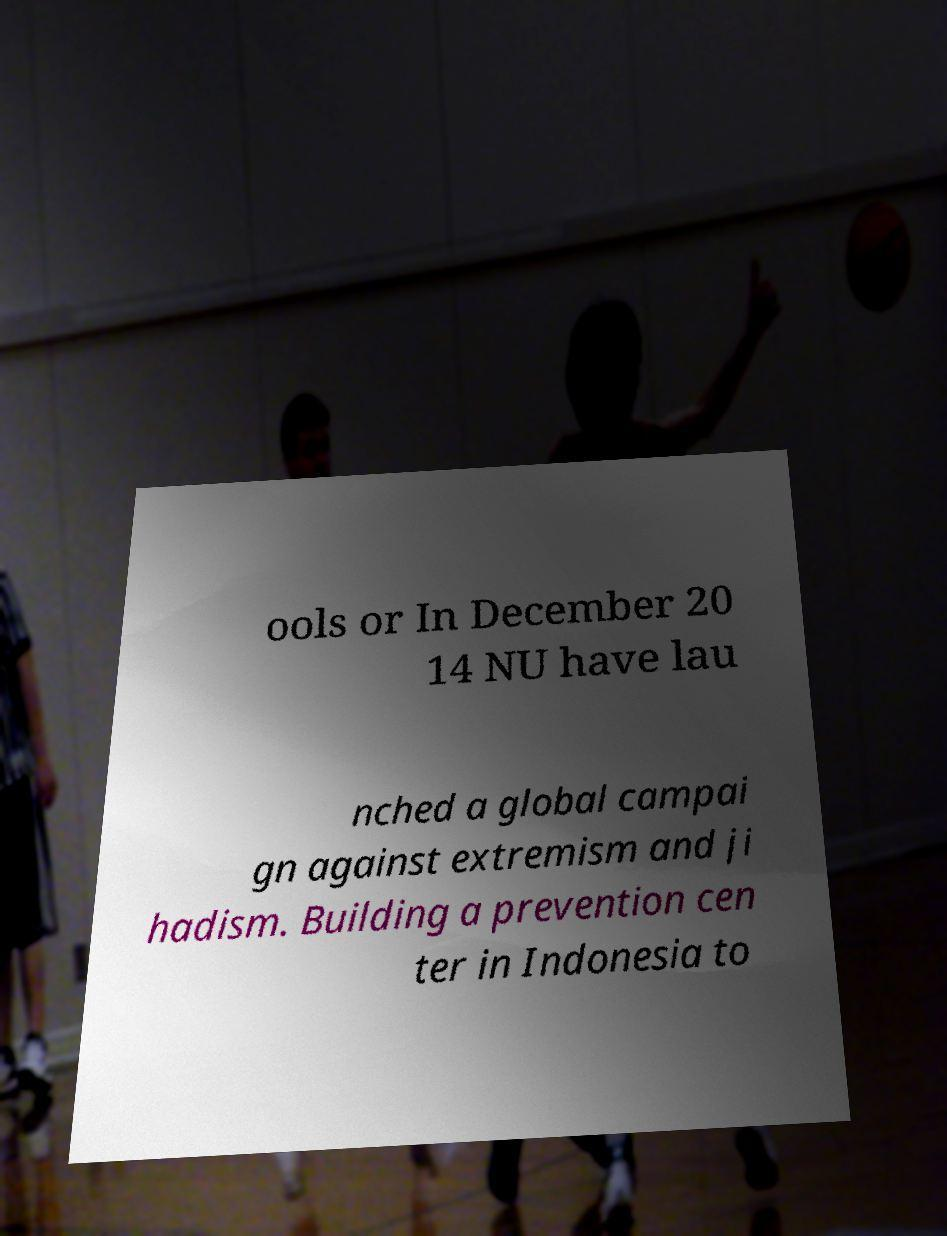Could you extract and type out the text from this image? ools or In December 20 14 NU have lau nched a global campai gn against extremism and ji hadism. Building a prevention cen ter in Indonesia to 